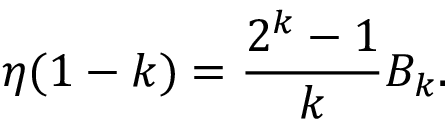Convert formula to latex. <formula><loc_0><loc_0><loc_500><loc_500>\eta ( 1 - k ) = { \frac { 2 ^ { k } - 1 } { k } } B _ { k } .</formula> 